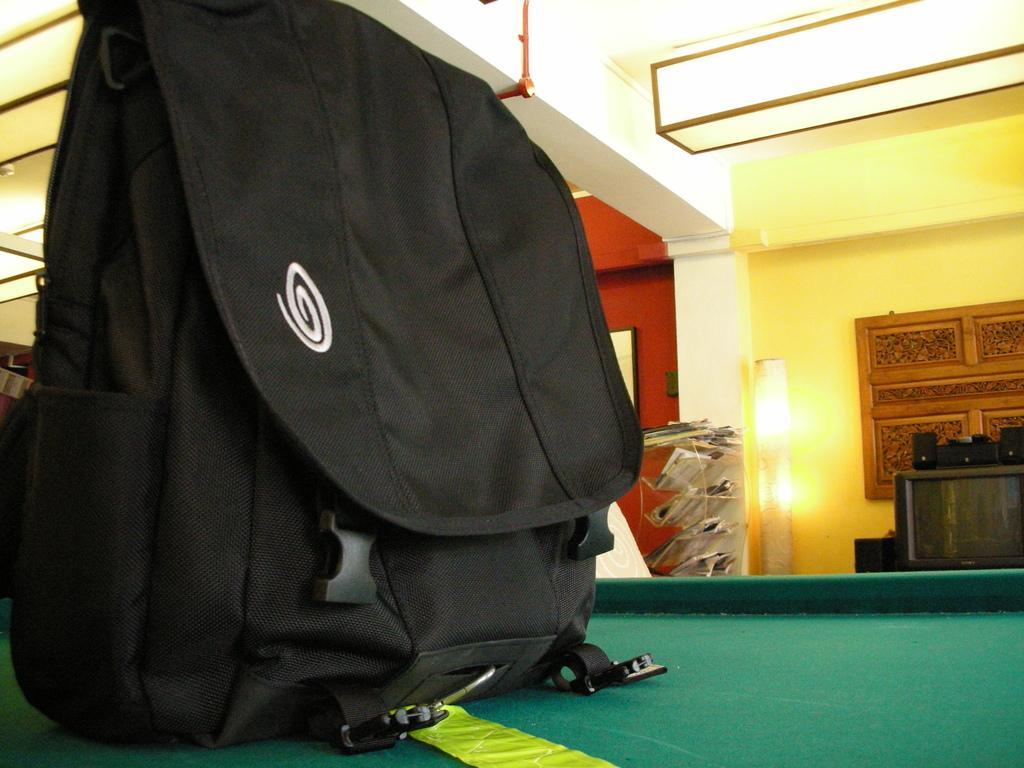What is located at the bottom of the image? There is a table at the bottom of the image. What is placed on the table? A bag is placed on the table. What can be seen in the background of the image? There is a television, a stand, and a wall in the background of the image. Where is the light located in the image? The light is at the top of the image. Can you observe the person's self in the bucket in the image? There is no bucket present in the image, and therefore no person's self can be observed in it. 